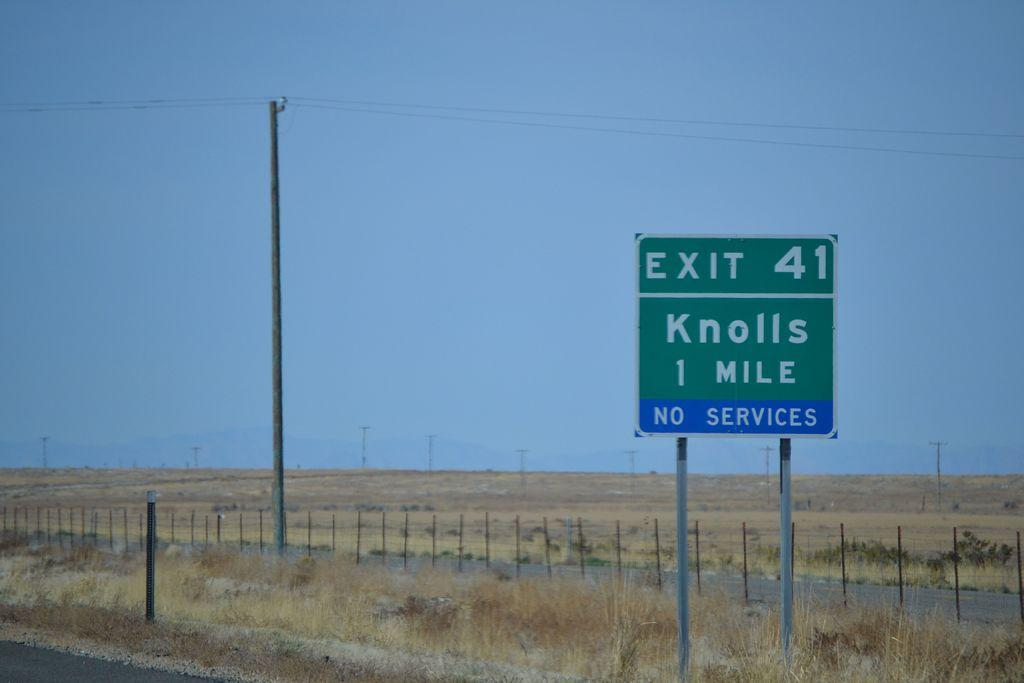<image>
Offer a succinct explanation of the picture presented. a knolls sign that is green among plains 